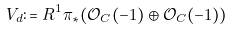<formula> <loc_0><loc_0><loc_500><loc_500>V _ { d } \colon = R ^ { 1 } \pi _ { * } ( \mathcal { O } _ { C } ( - 1 ) \oplus \mathcal { O } _ { C } ( - 1 ) )</formula> 